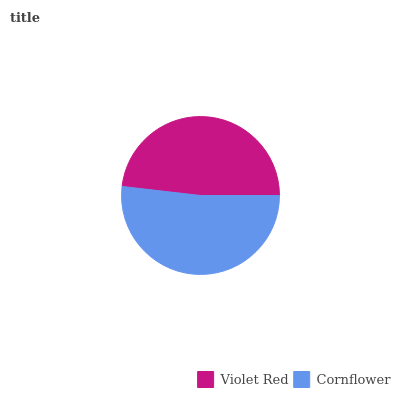Is Violet Red the minimum?
Answer yes or no. Yes. Is Cornflower the maximum?
Answer yes or no. Yes. Is Cornflower the minimum?
Answer yes or no. No. Is Cornflower greater than Violet Red?
Answer yes or no. Yes. Is Violet Red less than Cornflower?
Answer yes or no. Yes. Is Violet Red greater than Cornflower?
Answer yes or no. No. Is Cornflower less than Violet Red?
Answer yes or no. No. Is Cornflower the high median?
Answer yes or no. Yes. Is Violet Red the low median?
Answer yes or no. Yes. Is Violet Red the high median?
Answer yes or no. No. Is Cornflower the low median?
Answer yes or no. No. 